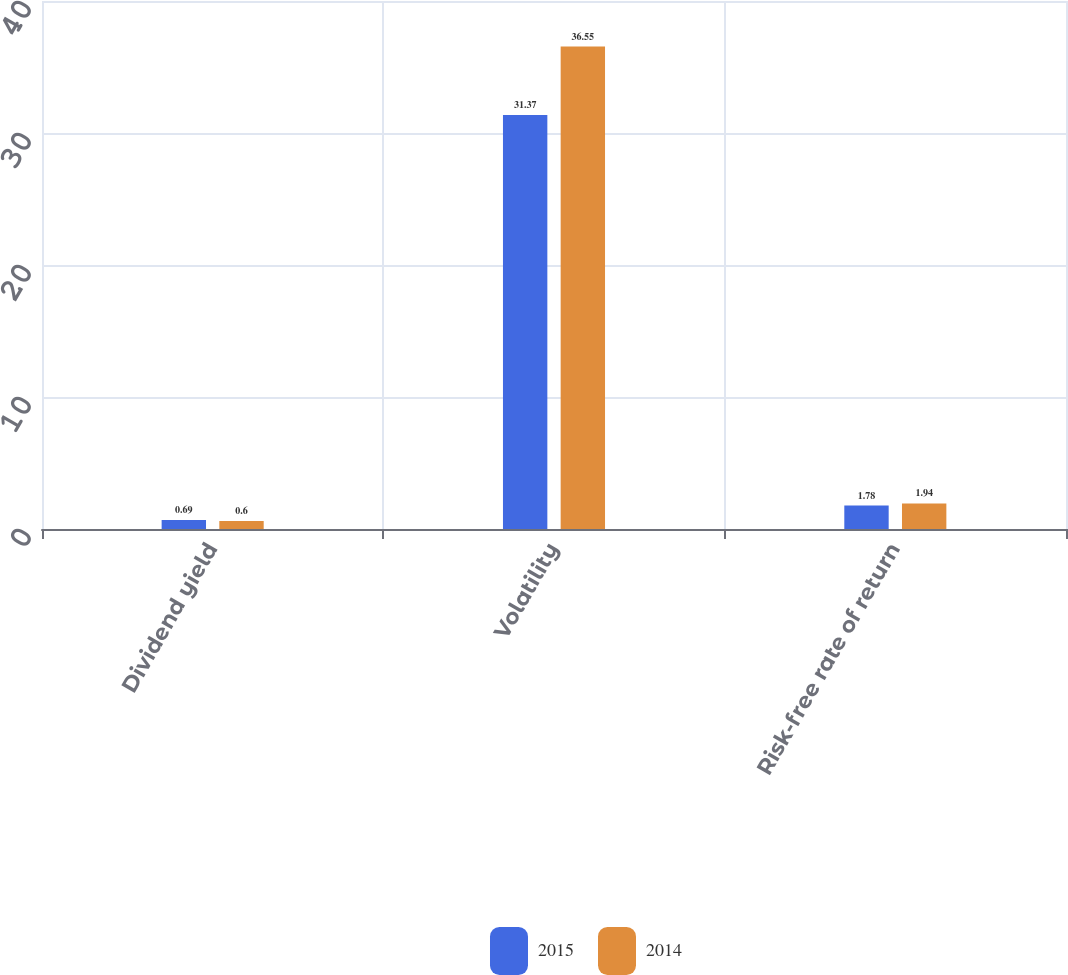Convert chart. <chart><loc_0><loc_0><loc_500><loc_500><stacked_bar_chart><ecel><fcel>Dividend yield<fcel>Volatility<fcel>Risk-free rate of return<nl><fcel>2015<fcel>0.69<fcel>31.37<fcel>1.78<nl><fcel>2014<fcel>0.6<fcel>36.55<fcel>1.94<nl></chart> 